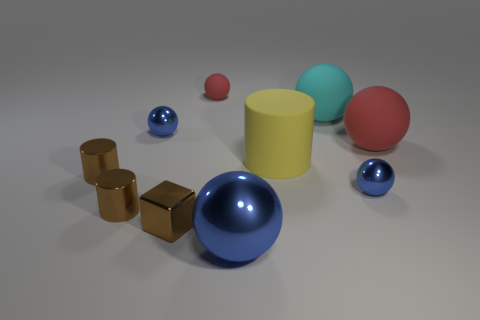Subtract all blue spheres. How many were subtracted if there are1blue spheres left? 2 Subtract all brown shiny cylinders. How many cylinders are left? 1 Subtract all red balls. How many balls are left? 4 Subtract 1 spheres. How many spheres are left? 5 Add 4 big shiny balls. How many big shiny balls are left? 5 Add 8 small brown cylinders. How many small brown cylinders exist? 10 Subtract 0 yellow balls. How many objects are left? 10 Subtract all balls. How many objects are left? 4 Subtract all purple cylinders. Subtract all yellow blocks. How many cylinders are left? 3 Subtract all brown cylinders. How many cyan spheres are left? 1 